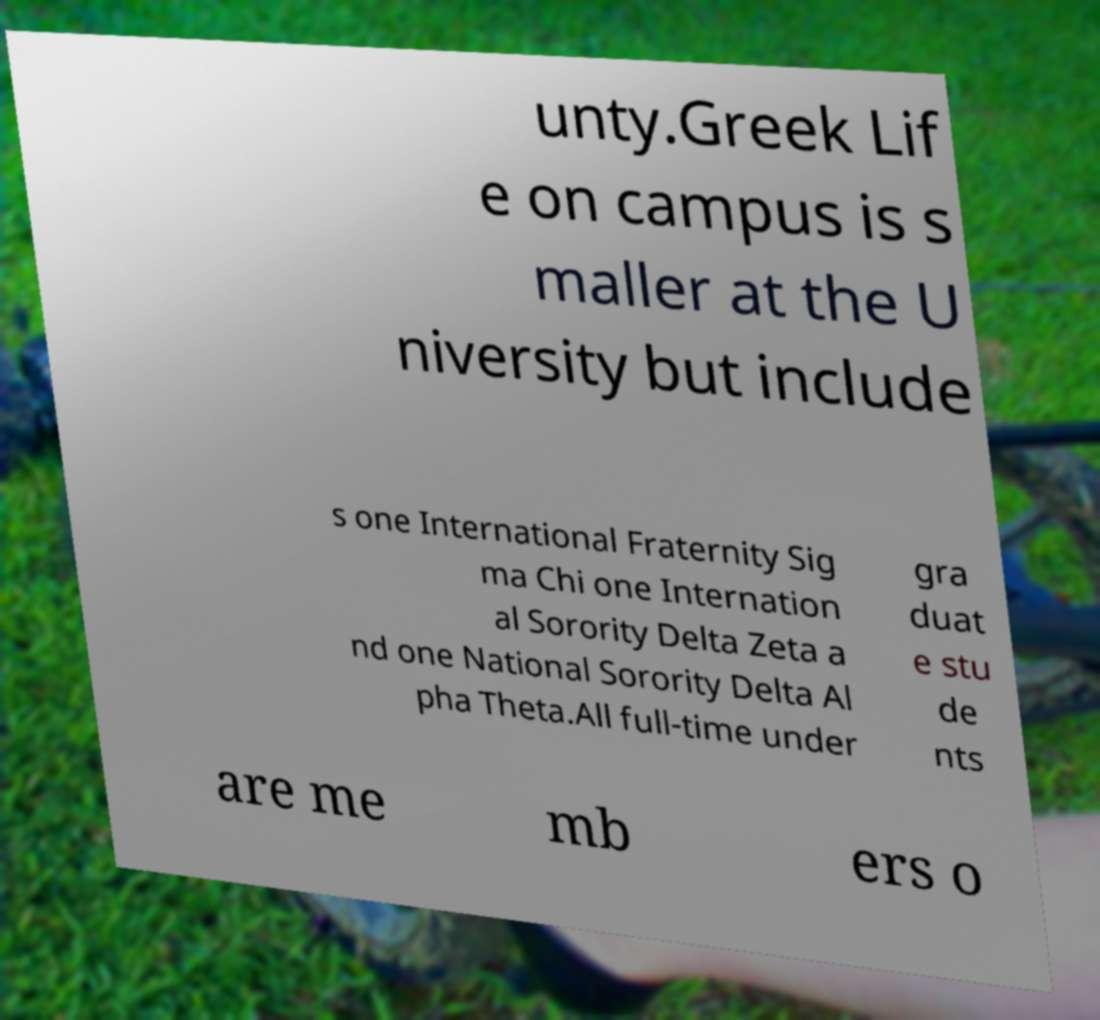There's text embedded in this image that I need extracted. Can you transcribe it verbatim? unty.Greek Lif e on campus is s maller at the U niversity but include s one International Fraternity Sig ma Chi one Internation al Sorority Delta Zeta a nd one National Sorority Delta Al pha Theta.All full-time under gra duat e stu de nts are me mb ers o 